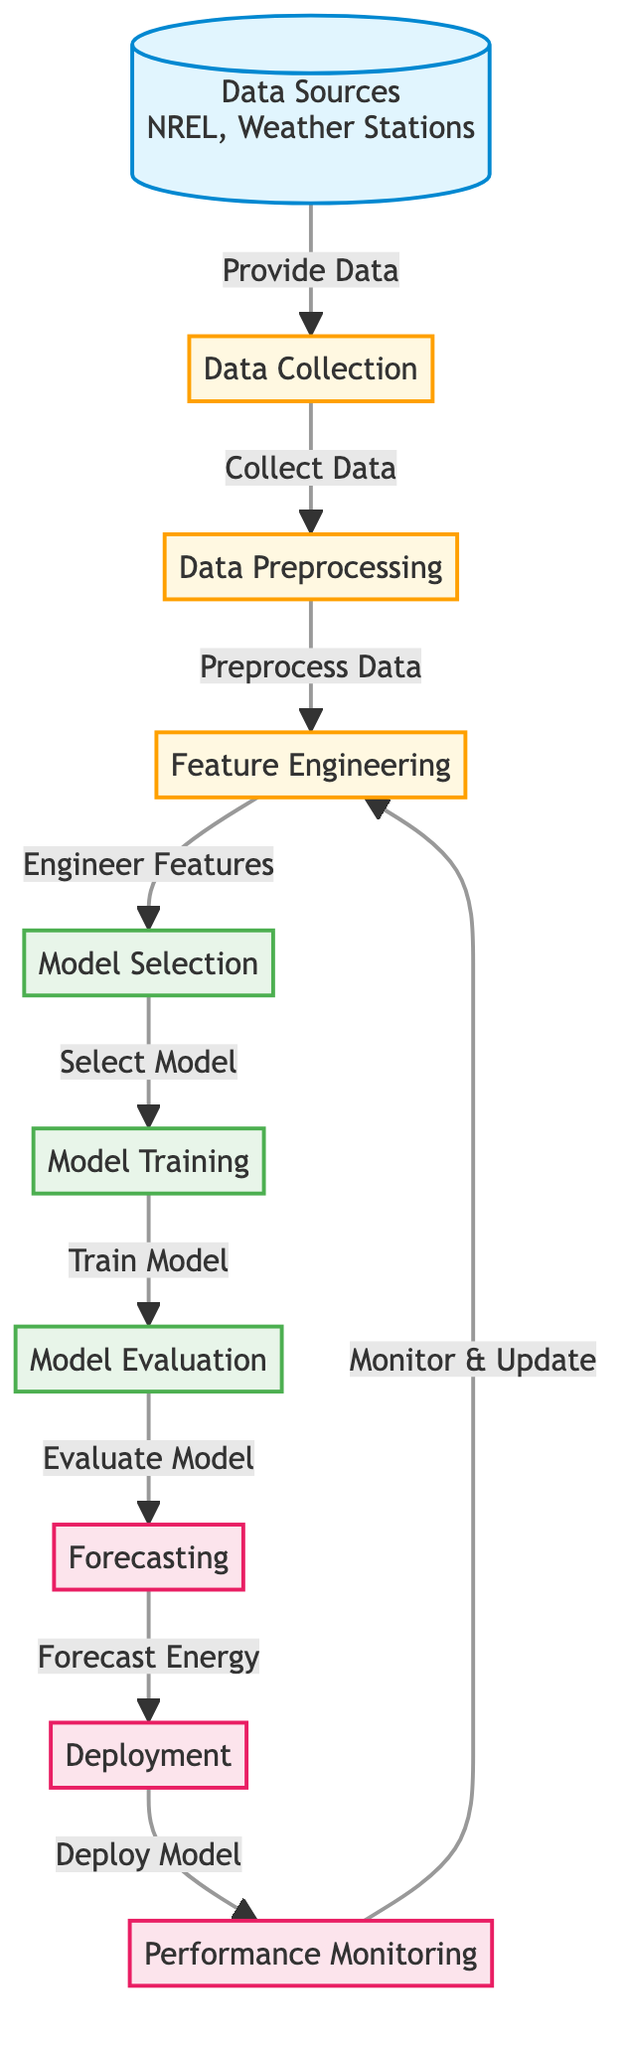What are the data sources mentioned in the diagram? The diagram lists "NREL" and "Weather Stations" as the data sources, as shown in the first node labeled "Data Sources."
Answer: NREL, Weather Stations How many nodes are in this diagram? By counting each distinct labeled node displayed in the diagram, there are a total of 10 nodes, including the starting and ending points.
Answer: 10 What process follows data preprocessing? The diagram shows that "Feature Engineering" directly follows the "Data Preprocessing" node, indicating the sequence in the workflow.
Answer: Feature Engineering Which stage leads to model training? According to the diagram, the "Model Selection" stage directly precedes "Model Training," indicating that the model selection is completed before training begins.
Answer: Model Selection What is the final outcome of the diagram? The diagram indicates that the last output node is "Performance Monitoring," representing the final outcome after the model deployment and ongoing monitoring activities.
Answer: Performance Monitoring What type of model is used for forecasting? The diagram does not specify the exact type of model but indicates that it's a "Model," suggesting a machine learning model is utilized in the general process of forecasting energy.
Answer: Model How does performance monitoring interact with feature engineering? The diagram illustrates a feedback loop where "Performance Monitoring" provides input back to "Feature Engineering," suggesting that monitoring results may lead to updated features being engineered.
Answer: Monitor & Update What is the process immediately after forecasting? The diagram clearly shows "Deployment" follows the "Forecasting" stage, signifying that once forecasting is completed, the model is deployed.
Answer: Deployment What is the purpose of model evaluation? In the diagram, "Model Evaluation" serves the purpose of evaluating the trained model's performance, capturing the quality of the model before making predictions.
Answer: Evaluate Model 